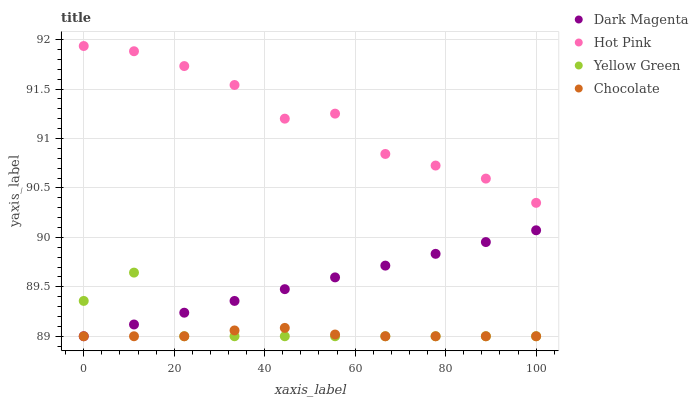Does Chocolate have the minimum area under the curve?
Answer yes or no. Yes. Does Hot Pink have the maximum area under the curve?
Answer yes or no. Yes. Does Dark Magenta have the minimum area under the curve?
Answer yes or no. No. Does Dark Magenta have the maximum area under the curve?
Answer yes or no. No. Is Dark Magenta the smoothest?
Answer yes or no. Yes. Is Yellow Green the roughest?
Answer yes or no. Yes. Is Hot Pink the smoothest?
Answer yes or no. No. Is Hot Pink the roughest?
Answer yes or no. No. Does Chocolate have the lowest value?
Answer yes or no. Yes. Does Hot Pink have the lowest value?
Answer yes or no. No. Does Hot Pink have the highest value?
Answer yes or no. Yes. Does Dark Magenta have the highest value?
Answer yes or no. No. Is Yellow Green less than Hot Pink?
Answer yes or no. Yes. Is Hot Pink greater than Yellow Green?
Answer yes or no. Yes. Does Yellow Green intersect Chocolate?
Answer yes or no. Yes. Is Yellow Green less than Chocolate?
Answer yes or no. No. Is Yellow Green greater than Chocolate?
Answer yes or no. No. Does Yellow Green intersect Hot Pink?
Answer yes or no. No. 